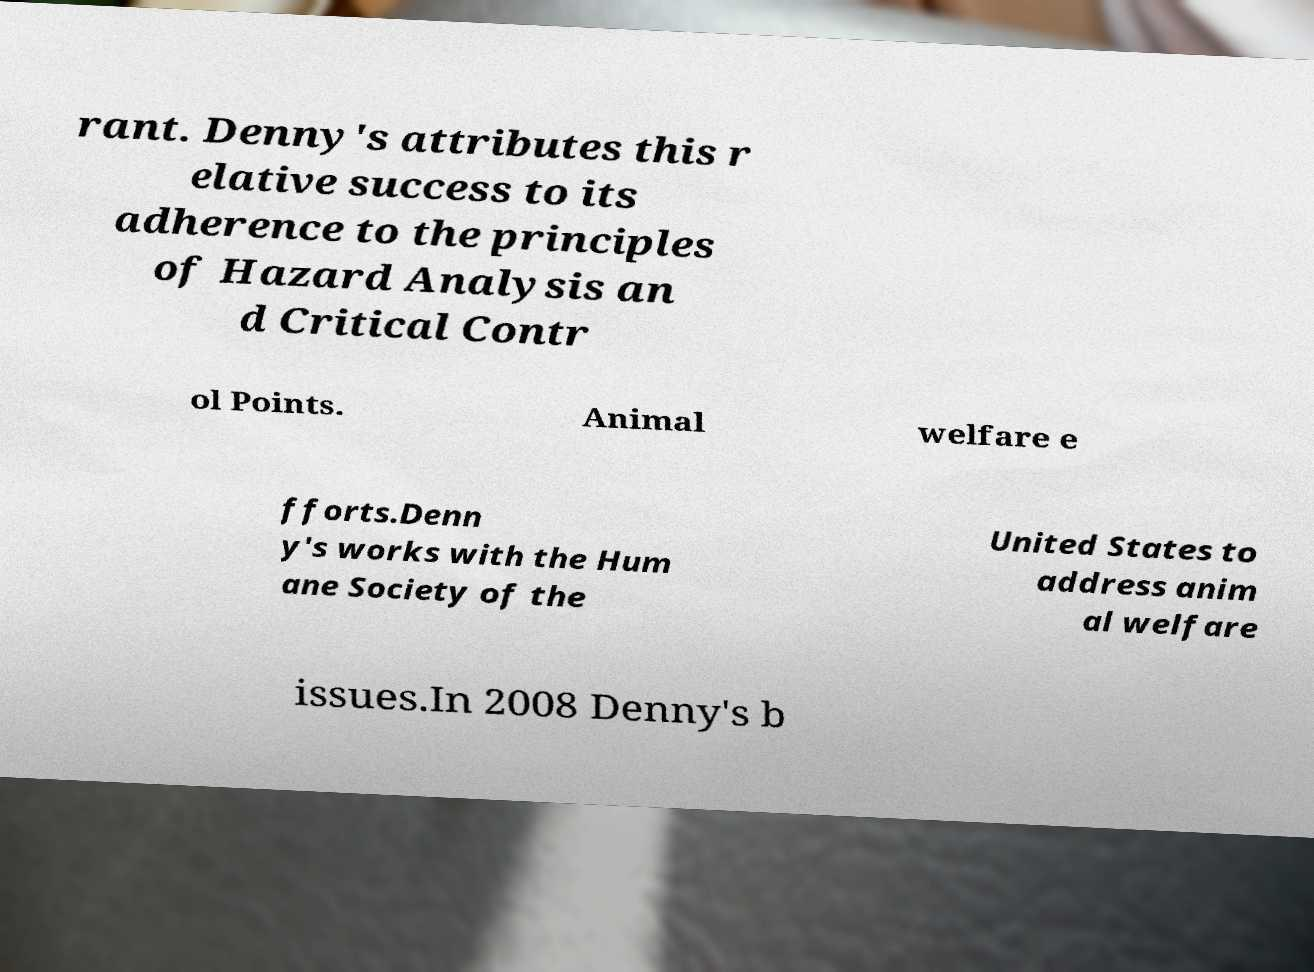Can you read and provide the text displayed in the image?This photo seems to have some interesting text. Can you extract and type it out for me? rant. Denny's attributes this r elative success to its adherence to the principles of Hazard Analysis an d Critical Contr ol Points. Animal welfare e fforts.Denn y's works with the Hum ane Society of the United States to address anim al welfare issues.In 2008 Denny's b 